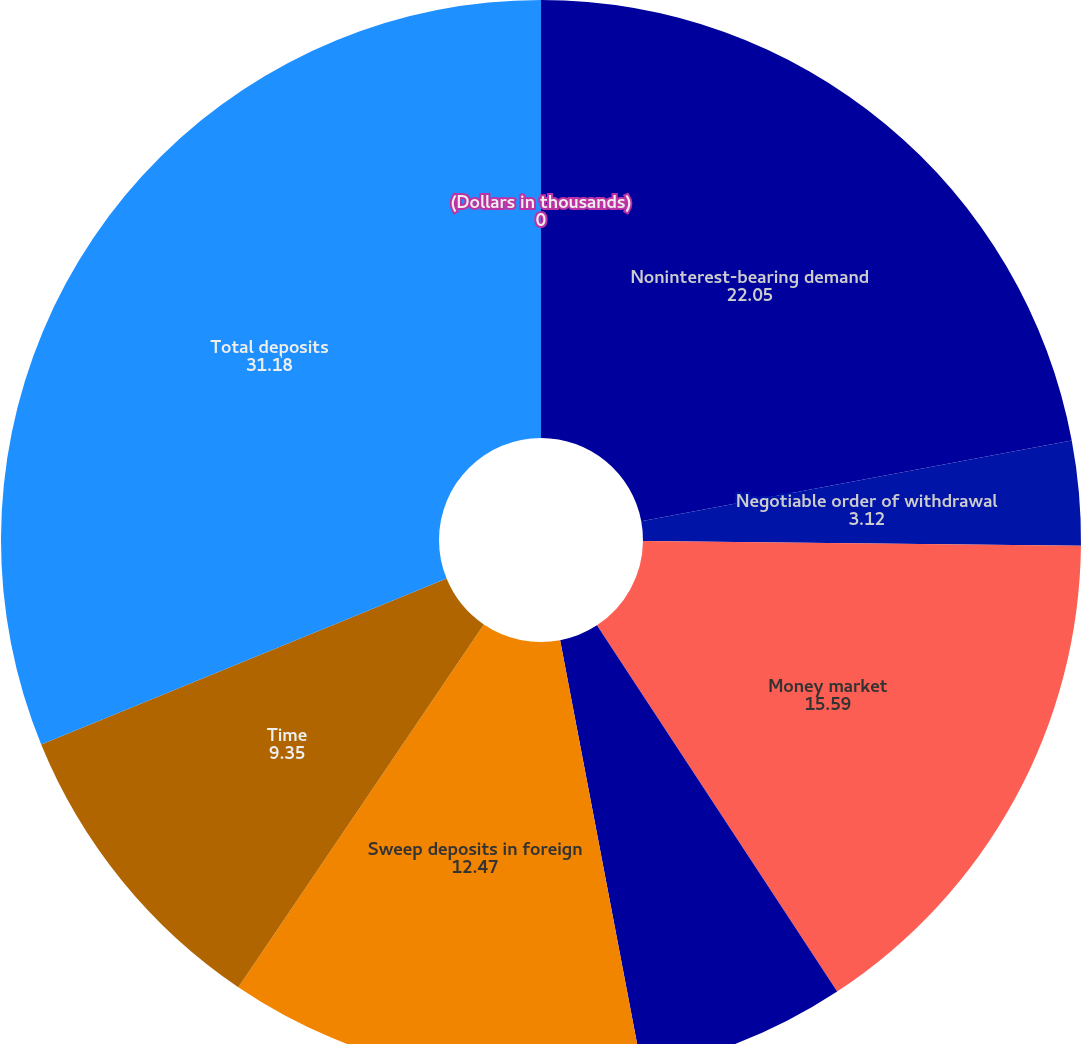Convert chart to OTSL. <chart><loc_0><loc_0><loc_500><loc_500><pie_chart><fcel>(Dollars in thousands)<fcel>Noninterest-bearing demand<fcel>Negotiable order of withdrawal<fcel>Money market<fcel>Money market deposits in<fcel>Sweep deposits in foreign<fcel>Time<fcel>Total deposits<nl><fcel>0.0%<fcel>22.05%<fcel>3.12%<fcel>15.59%<fcel>6.24%<fcel>12.47%<fcel>9.35%<fcel>31.18%<nl></chart> 